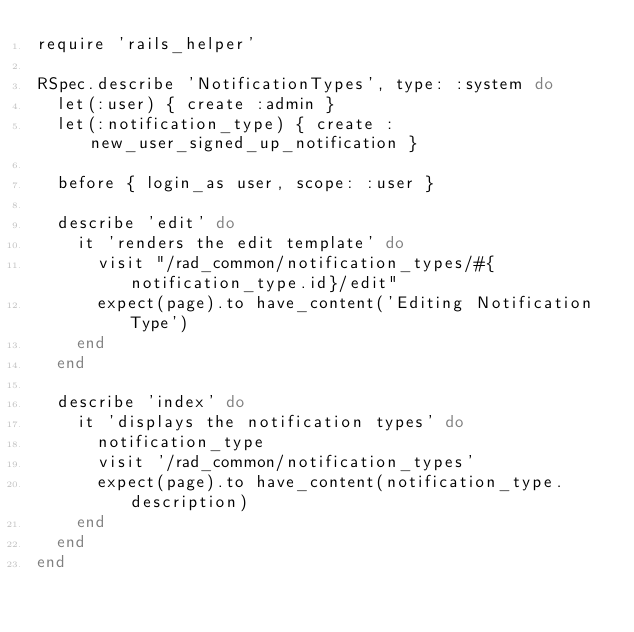<code> <loc_0><loc_0><loc_500><loc_500><_Ruby_>require 'rails_helper'

RSpec.describe 'NotificationTypes', type: :system do
  let(:user) { create :admin }
  let(:notification_type) { create :new_user_signed_up_notification }

  before { login_as user, scope: :user }

  describe 'edit' do
    it 'renders the edit template' do
      visit "/rad_common/notification_types/#{notification_type.id}/edit"
      expect(page).to have_content('Editing Notification Type')
    end
  end

  describe 'index' do
    it 'displays the notification types' do
      notification_type
      visit '/rad_common/notification_types'
      expect(page).to have_content(notification_type.description)
    end
  end
end
</code> 